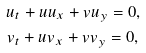Convert formula to latex. <formula><loc_0><loc_0><loc_500><loc_500>& u _ { t } + u u _ { x } + v u _ { y } = 0 , \\ & v _ { t } + u v _ { x } + v v _ { y } = 0 ,</formula> 